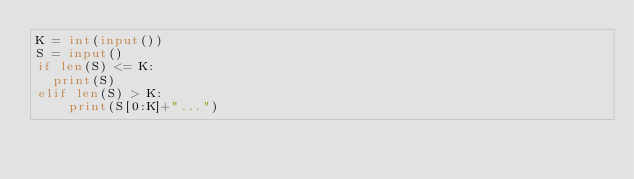<code> <loc_0><loc_0><loc_500><loc_500><_Python_>K = int(input())
S = input()
if len(S) <= K:
	print(S)
elif len(S) > K:
    print(S[0:K]+"...")</code> 